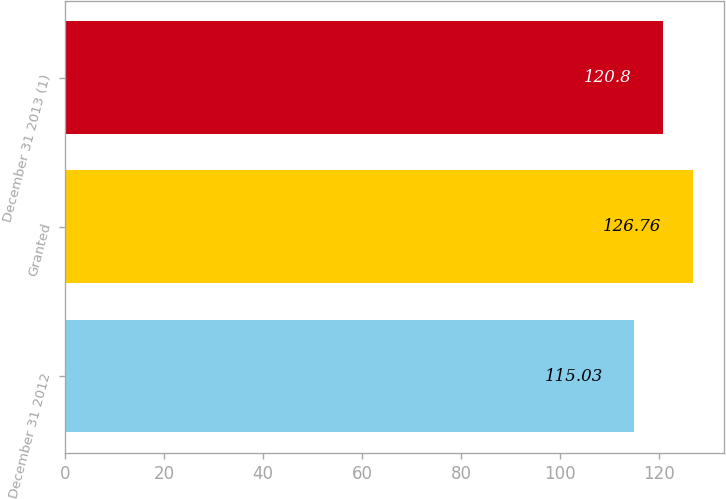<chart> <loc_0><loc_0><loc_500><loc_500><bar_chart><fcel>December 31 2012<fcel>Granted<fcel>December 31 2013 (1)<nl><fcel>115.03<fcel>126.76<fcel>120.8<nl></chart> 